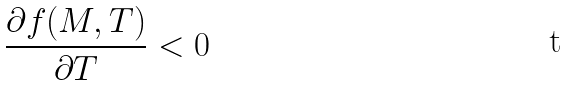<formula> <loc_0><loc_0><loc_500><loc_500>\frac { \partial f ( M , T ) } { \partial T } < 0</formula> 